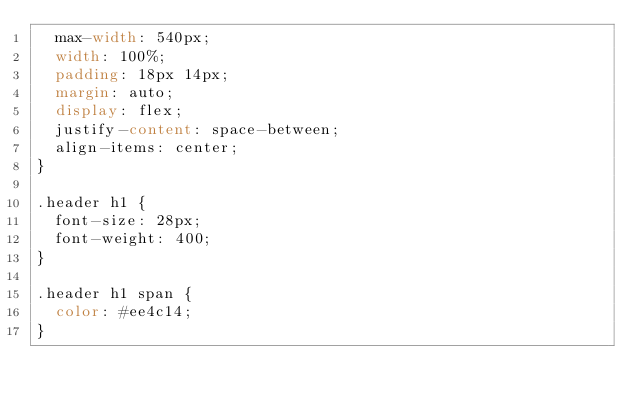Convert code to text. <code><loc_0><loc_0><loc_500><loc_500><_CSS_>  max-width: 540px;
  width: 100%;
  padding: 18px 14px;
  margin: auto;
  display: flex;
  justify-content: space-between;
  align-items: center;
}

.header h1 {
  font-size: 28px;
  font-weight: 400;
}

.header h1 span {
  color: #ee4c14;
}
</code> 